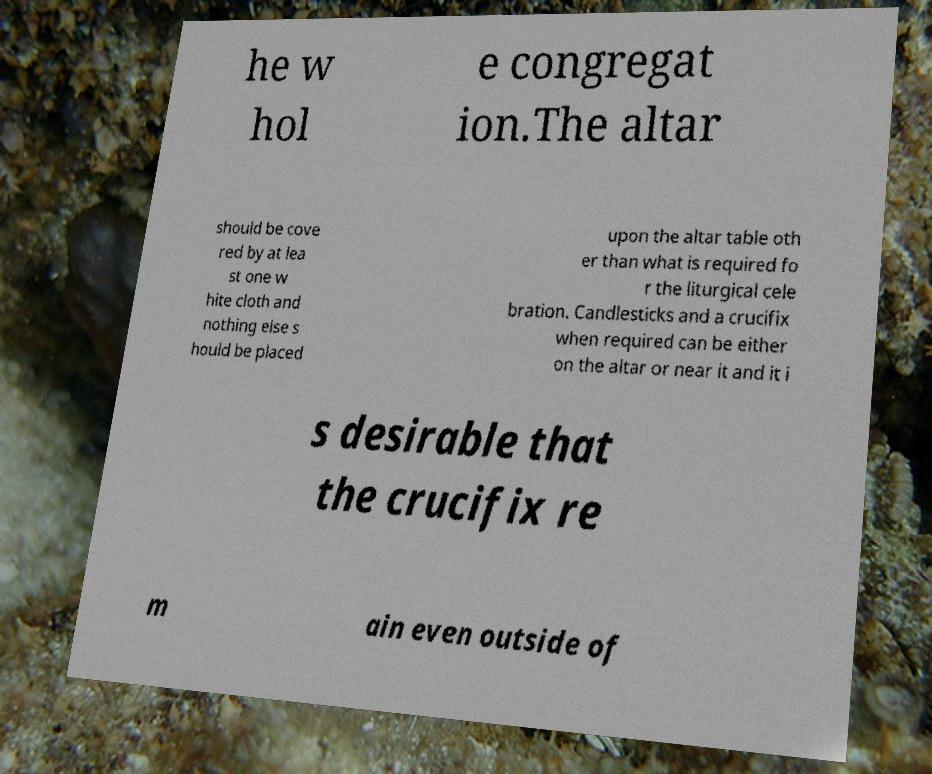Can you read and provide the text displayed in the image?This photo seems to have some interesting text. Can you extract and type it out for me? he w hol e congregat ion.The altar should be cove red by at lea st one w hite cloth and nothing else s hould be placed upon the altar table oth er than what is required fo r the liturgical cele bration. Candlesticks and a crucifix when required can be either on the altar or near it and it i s desirable that the crucifix re m ain even outside of 